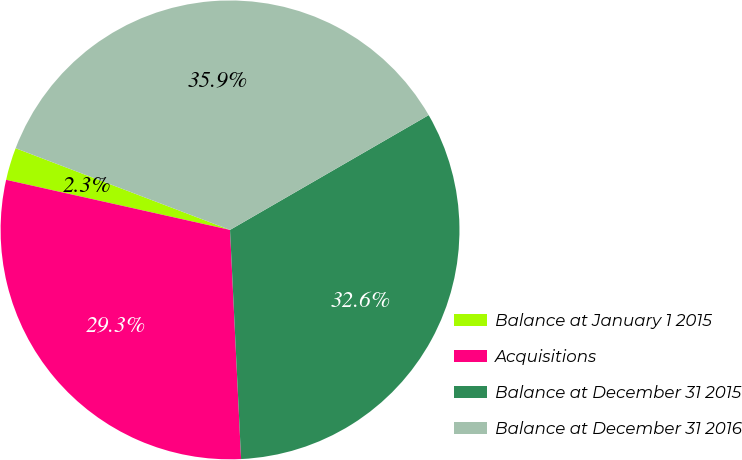Convert chart. <chart><loc_0><loc_0><loc_500><loc_500><pie_chart><fcel>Balance at January 1 2015<fcel>Acquisitions<fcel>Balance at December 31 2015<fcel>Balance at December 31 2016<nl><fcel>2.29%<fcel>29.27%<fcel>32.57%<fcel>35.87%<nl></chart> 